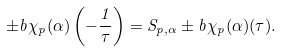<formula> <loc_0><loc_0><loc_500><loc_500>\pm b { \chi } _ { p } ( \alpha ) \left ( - \frac { 1 } { \tau } \right ) = S _ { p , \alpha } \pm b { \chi } _ { p } ( \alpha ) ( \tau ) .</formula> 